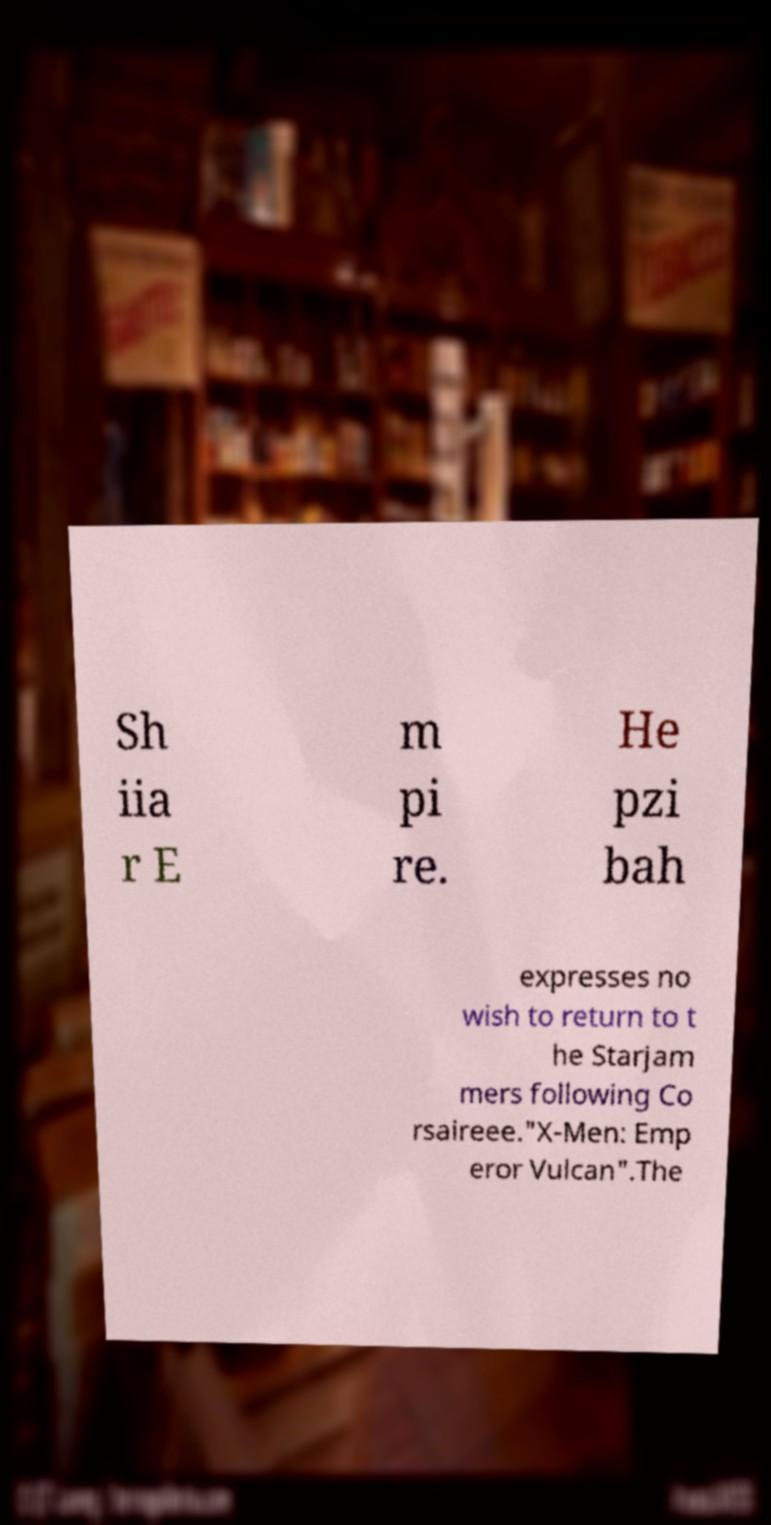Could you extract and type out the text from this image? Sh iia r E m pi re. He pzi bah expresses no wish to return to t he Starjam mers following Co rsaireee."X-Men: Emp eror Vulcan".The 